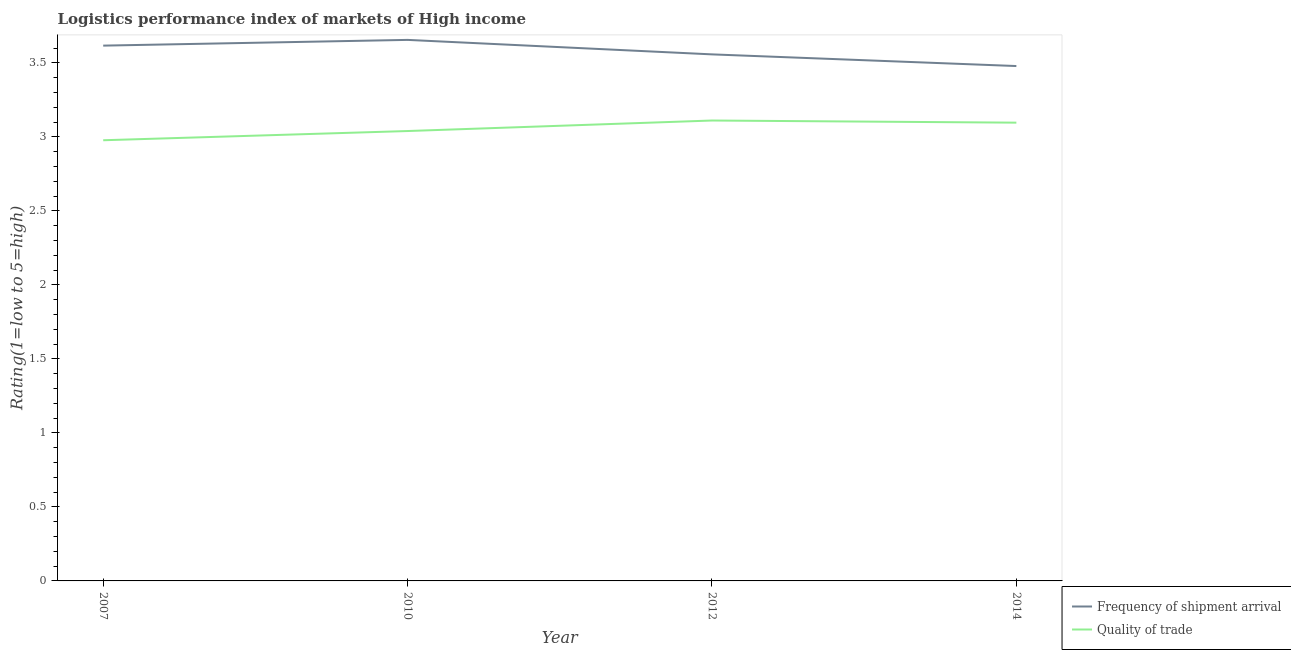Does the line corresponding to lpi quality of trade intersect with the line corresponding to lpi of frequency of shipment arrival?
Ensure brevity in your answer.  No. What is the lpi of frequency of shipment arrival in 2014?
Your answer should be compact. 3.48. Across all years, what is the maximum lpi quality of trade?
Offer a very short reply. 3.11. Across all years, what is the minimum lpi quality of trade?
Ensure brevity in your answer.  2.98. In which year was the lpi quality of trade minimum?
Ensure brevity in your answer.  2007. What is the total lpi quality of trade in the graph?
Give a very brief answer. 12.23. What is the difference between the lpi of frequency of shipment arrival in 2010 and that in 2014?
Your answer should be very brief. 0.18. What is the difference between the lpi of frequency of shipment arrival in 2012 and the lpi quality of trade in 2014?
Keep it short and to the point. 0.46. What is the average lpi quality of trade per year?
Your answer should be compact. 3.06. In the year 2007, what is the difference between the lpi of frequency of shipment arrival and lpi quality of trade?
Offer a very short reply. 0.64. What is the ratio of the lpi of frequency of shipment arrival in 2012 to that in 2014?
Provide a short and direct response. 1.02. Is the lpi quality of trade in 2007 less than that in 2014?
Keep it short and to the point. Yes. What is the difference between the highest and the second highest lpi quality of trade?
Offer a terse response. 0.01. What is the difference between the highest and the lowest lpi of frequency of shipment arrival?
Provide a succinct answer. 0.18. Does the lpi quality of trade monotonically increase over the years?
Offer a very short reply. No. How many years are there in the graph?
Provide a short and direct response. 4. Does the graph contain grids?
Offer a very short reply. No. How many legend labels are there?
Make the answer very short. 2. What is the title of the graph?
Make the answer very short. Logistics performance index of markets of High income. Does "Female labourers" appear as one of the legend labels in the graph?
Provide a succinct answer. No. What is the label or title of the Y-axis?
Your answer should be very brief. Rating(1=low to 5=high). What is the Rating(1=low to 5=high) in Frequency of shipment arrival in 2007?
Offer a terse response. 3.62. What is the Rating(1=low to 5=high) of Quality of trade in 2007?
Ensure brevity in your answer.  2.98. What is the Rating(1=low to 5=high) in Frequency of shipment arrival in 2010?
Keep it short and to the point. 3.66. What is the Rating(1=low to 5=high) of Quality of trade in 2010?
Provide a succinct answer. 3.04. What is the Rating(1=low to 5=high) in Frequency of shipment arrival in 2012?
Make the answer very short. 3.56. What is the Rating(1=low to 5=high) of Quality of trade in 2012?
Your answer should be very brief. 3.11. What is the Rating(1=low to 5=high) in Frequency of shipment arrival in 2014?
Provide a succinct answer. 3.48. What is the Rating(1=low to 5=high) in Quality of trade in 2014?
Offer a terse response. 3.1. Across all years, what is the maximum Rating(1=low to 5=high) in Frequency of shipment arrival?
Make the answer very short. 3.66. Across all years, what is the maximum Rating(1=low to 5=high) of Quality of trade?
Provide a succinct answer. 3.11. Across all years, what is the minimum Rating(1=low to 5=high) of Frequency of shipment arrival?
Provide a succinct answer. 3.48. Across all years, what is the minimum Rating(1=low to 5=high) of Quality of trade?
Ensure brevity in your answer.  2.98. What is the total Rating(1=low to 5=high) in Frequency of shipment arrival in the graph?
Your response must be concise. 14.31. What is the total Rating(1=low to 5=high) of Quality of trade in the graph?
Your answer should be compact. 12.23. What is the difference between the Rating(1=low to 5=high) of Frequency of shipment arrival in 2007 and that in 2010?
Your response must be concise. -0.04. What is the difference between the Rating(1=low to 5=high) in Quality of trade in 2007 and that in 2010?
Offer a very short reply. -0.06. What is the difference between the Rating(1=low to 5=high) in Frequency of shipment arrival in 2007 and that in 2012?
Keep it short and to the point. 0.06. What is the difference between the Rating(1=low to 5=high) of Quality of trade in 2007 and that in 2012?
Your answer should be compact. -0.13. What is the difference between the Rating(1=low to 5=high) in Frequency of shipment arrival in 2007 and that in 2014?
Your answer should be compact. 0.14. What is the difference between the Rating(1=low to 5=high) of Quality of trade in 2007 and that in 2014?
Offer a terse response. -0.12. What is the difference between the Rating(1=low to 5=high) in Frequency of shipment arrival in 2010 and that in 2012?
Your response must be concise. 0.1. What is the difference between the Rating(1=low to 5=high) of Quality of trade in 2010 and that in 2012?
Your answer should be compact. -0.07. What is the difference between the Rating(1=low to 5=high) of Frequency of shipment arrival in 2010 and that in 2014?
Offer a very short reply. 0.18. What is the difference between the Rating(1=low to 5=high) in Quality of trade in 2010 and that in 2014?
Give a very brief answer. -0.06. What is the difference between the Rating(1=low to 5=high) in Frequency of shipment arrival in 2012 and that in 2014?
Offer a very short reply. 0.08. What is the difference between the Rating(1=low to 5=high) of Quality of trade in 2012 and that in 2014?
Make the answer very short. 0.01. What is the difference between the Rating(1=low to 5=high) of Frequency of shipment arrival in 2007 and the Rating(1=low to 5=high) of Quality of trade in 2010?
Keep it short and to the point. 0.58. What is the difference between the Rating(1=low to 5=high) in Frequency of shipment arrival in 2007 and the Rating(1=low to 5=high) in Quality of trade in 2012?
Your response must be concise. 0.51. What is the difference between the Rating(1=low to 5=high) of Frequency of shipment arrival in 2007 and the Rating(1=low to 5=high) of Quality of trade in 2014?
Your answer should be compact. 0.52. What is the difference between the Rating(1=low to 5=high) of Frequency of shipment arrival in 2010 and the Rating(1=low to 5=high) of Quality of trade in 2012?
Give a very brief answer. 0.54. What is the difference between the Rating(1=low to 5=high) of Frequency of shipment arrival in 2010 and the Rating(1=low to 5=high) of Quality of trade in 2014?
Offer a terse response. 0.56. What is the difference between the Rating(1=low to 5=high) of Frequency of shipment arrival in 2012 and the Rating(1=low to 5=high) of Quality of trade in 2014?
Your response must be concise. 0.46. What is the average Rating(1=low to 5=high) of Frequency of shipment arrival per year?
Your answer should be very brief. 3.58. What is the average Rating(1=low to 5=high) of Quality of trade per year?
Offer a very short reply. 3.06. In the year 2007, what is the difference between the Rating(1=low to 5=high) of Frequency of shipment arrival and Rating(1=low to 5=high) of Quality of trade?
Give a very brief answer. 0.64. In the year 2010, what is the difference between the Rating(1=low to 5=high) of Frequency of shipment arrival and Rating(1=low to 5=high) of Quality of trade?
Provide a short and direct response. 0.62. In the year 2012, what is the difference between the Rating(1=low to 5=high) of Frequency of shipment arrival and Rating(1=low to 5=high) of Quality of trade?
Your answer should be compact. 0.45. In the year 2014, what is the difference between the Rating(1=low to 5=high) in Frequency of shipment arrival and Rating(1=low to 5=high) in Quality of trade?
Your answer should be very brief. 0.38. What is the ratio of the Rating(1=low to 5=high) of Quality of trade in 2007 to that in 2010?
Make the answer very short. 0.98. What is the ratio of the Rating(1=low to 5=high) in Frequency of shipment arrival in 2007 to that in 2012?
Your answer should be very brief. 1.02. What is the ratio of the Rating(1=low to 5=high) in Quality of trade in 2007 to that in 2012?
Your response must be concise. 0.96. What is the ratio of the Rating(1=low to 5=high) in Frequency of shipment arrival in 2007 to that in 2014?
Your response must be concise. 1.04. What is the ratio of the Rating(1=low to 5=high) in Quality of trade in 2007 to that in 2014?
Keep it short and to the point. 0.96. What is the ratio of the Rating(1=low to 5=high) in Frequency of shipment arrival in 2010 to that in 2012?
Offer a terse response. 1.03. What is the ratio of the Rating(1=low to 5=high) of Quality of trade in 2010 to that in 2012?
Your answer should be compact. 0.98. What is the ratio of the Rating(1=low to 5=high) of Frequency of shipment arrival in 2010 to that in 2014?
Your answer should be very brief. 1.05. What is the ratio of the Rating(1=low to 5=high) in Quality of trade in 2010 to that in 2014?
Your answer should be very brief. 0.98. What is the ratio of the Rating(1=low to 5=high) in Frequency of shipment arrival in 2012 to that in 2014?
Give a very brief answer. 1.02. What is the ratio of the Rating(1=low to 5=high) in Quality of trade in 2012 to that in 2014?
Provide a short and direct response. 1. What is the difference between the highest and the second highest Rating(1=low to 5=high) of Frequency of shipment arrival?
Offer a very short reply. 0.04. What is the difference between the highest and the second highest Rating(1=low to 5=high) of Quality of trade?
Provide a short and direct response. 0.01. What is the difference between the highest and the lowest Rating(1=low to 5=high) of Frequency of shipment arrival?
Offer a terse response. 0.18. What is the difference between the highest and the lowest Rating(1=low to 5=high) in Quality of trade?
Give a very brief answer. 0.13. 